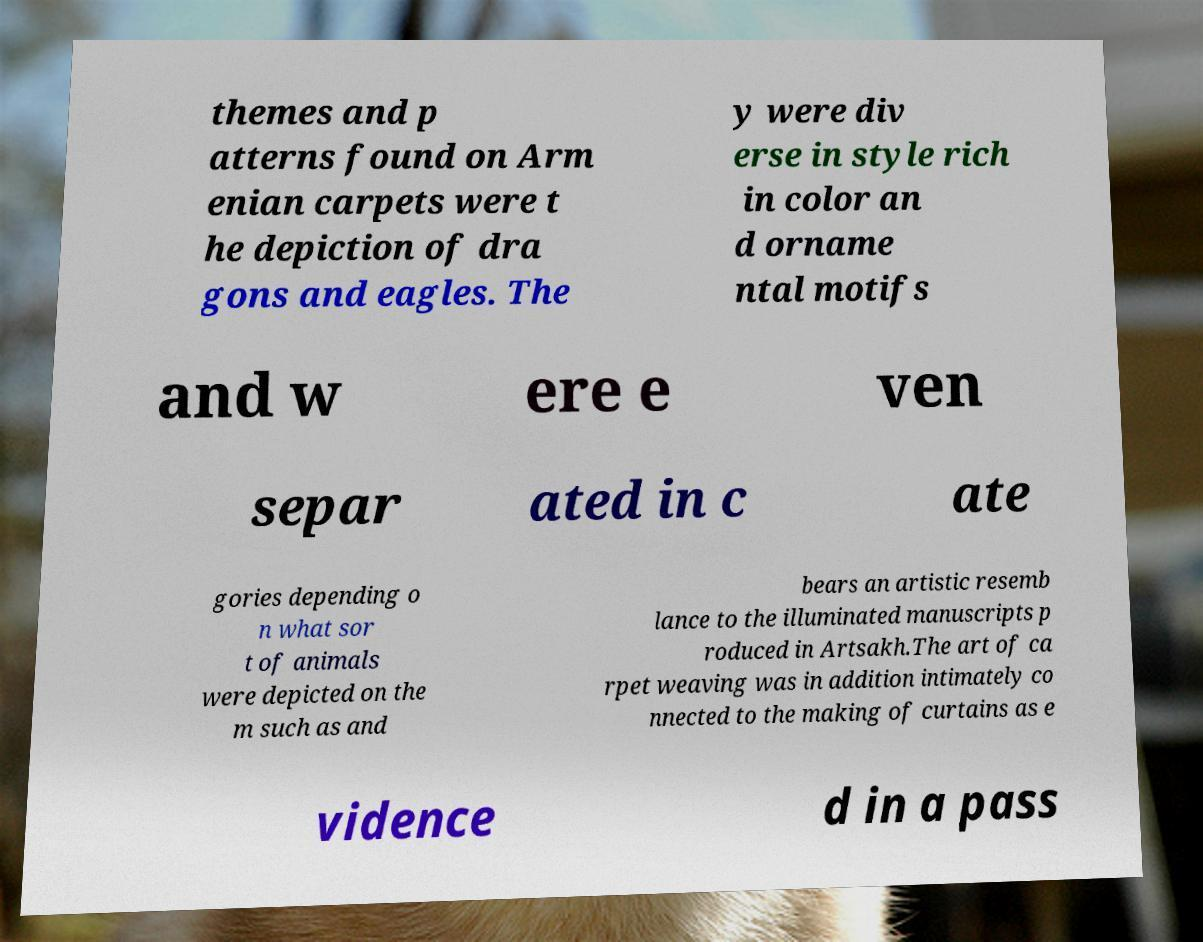Please read and relay the text visible in this image. What does it say? themes and p atterns found on Arm enian carpets were t he depiction of dra gons and eagles. The y were div erse in style rich in color an d orname ntal motifs and w ere e ven separ ated in c ate gories depending o n what sor t of animals were depicted on the m such as and bears an artistic resemb lance to the illuminated manuscripts p roduced in Artsakh.The art of ca rpet weaving was in addition intimately co nnected to the making of curtains as e vidence d in a pass 